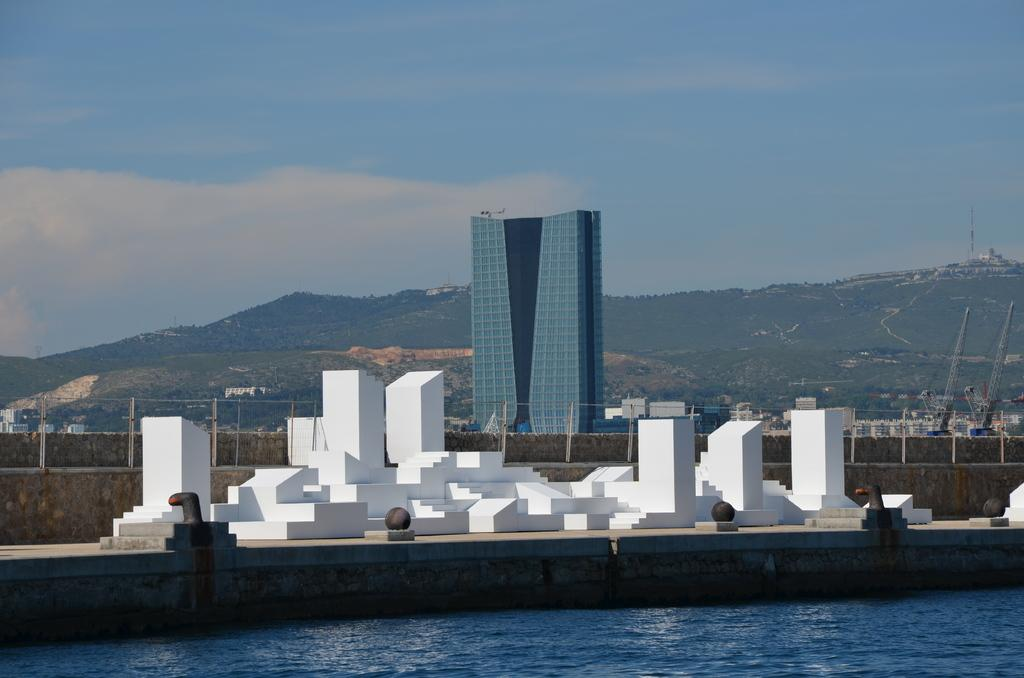What is the primary element present in the image? There is water in the image. What structures can be seen in the image? There are buildings in the image. What is located in the background of the image? There is a fence, cranes, and hills in the background of the image. What can be seen in the sky in the image? There are clouds visible in the image. How many houses are visible on the coast in the image? There is no coast or houses present in the image. What type of boundary is created by the fence in the image? There is no boundary mentioned in the image, as the focus is on the fence itself and not its purpose. 